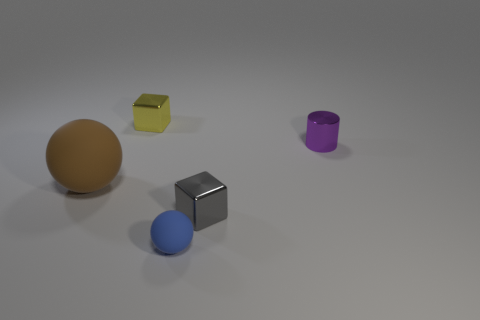Add 1 big spheres. How many objects exist? 6 Subtract all brown balls. How many balls are left? 1 Subtract 1 cylinders. How many cylinders are left? 0 Subtract 0 yellow balls. How many objects are left? 5 Subtract all blocks. How many objects are left? 3 Subtract all blue cubes. Subtract all green cylinders. How many cubes are left? 2 Subtract all tiny cubes. Subtract all purple cylinders. How many objects are left? 2 Add 3 gray metallic objects. How many gray metallic objects are left? 4 Add 4 tiny red metal objects. How many tiny red metal objects exist? 4 